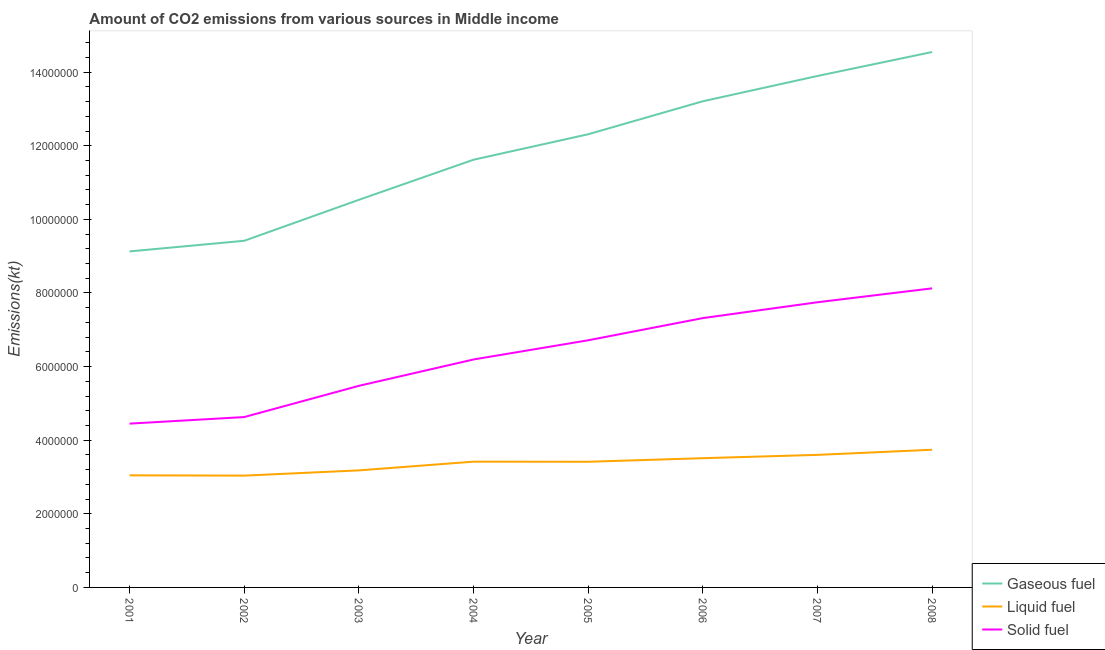How many different coloured lines are there?
Your answer should be very brief. 3. Does the line corresponding to amount of co2 emissions from gaseous fuel intersect with the line corresponding to amount of co2 emissions from solid fuel?
Provide a succinct answer. No. What is the amount of co2 emissions from solid fuel in 2003?
Ensure brevity in your answer.  5.48e+06. Across all years, what is the maximum amount of co2 emissions from gaseous fuel?
Ensure brevity in your answer.  1.45e+07. Across all years, what is the minimum amount of co2 emissions from liquid fuel?
Your answer should be very brief. 3.04e+06. In which year was the amount of co2 emissions from gaseous fuel maximum?
Your response must be concise. 2008. What is the total amount of co2 emissions from solid fuel in the graph?
Make the answer very short. 5.07e+07. What is the difference between the amount of co2 emissions from gaseous fuel in 2003 and that in 2008?
Give a very brief answer. -4.02e+06. What is the difference between the amount of co2 emissions from liquid fuel in 2008 and the amount of co2 emissions from solid fuel in 2001?
Keep it short and to the point. -7.10e+05. What is the average amount of co2 emissions from gaseous fuel per year?
Your answer should be compact. 1.18e+07. In the year 2008, what is the difference between the amount of co2 emissions from liquid fuel and amount of co2 emissions from gaseous fuel?
Your response must be concise. -1.08e+07. In how many years, is the amount of co2 emissions from gaseous fuel greater than 12000000 kt?
Your answer should be very brief. 4. What is the ratio of the amount of co2 emissions from liquid fuel in 2001 to that in 2008?
Provide a short and direct response. 0.81. Is the difference between the amount of co2 emissions from gaseous fuel in 2006 and 2008 greater than the difference between the amount of co2 emissions from solid fuel in 2006 and 2008?
Your answer should be compact. No. What is the difference between the highest and the second highest amount of co2 emissions from solid fuel?
Give a very brief answer. 3.77e+05. What is the difference between the highest and the lowest amount of co2 emissions from solid fuel?
Provide a short and direct response. 3.68e+06. In how many years, is the amount of co2 emissions from liquid fuel greater than the average amount of co2 emissions from liquid fuel taken over all years?
Make the answer very short. 5. Is it the case that in every year, the sum of the amount of co2 emissions from gaseous fuel and amount of co2 emissions from liquid fuel is greater than the amount of co2 emissions from solid fuel?
Give a very brief answer. Yes. Is the amount of co2 emissions from solid fuel strictly less than the amount of co2 emissions from liquid fuel over the years?
Your answer should be compact. No. How many years are there in the graph?
Offer a terse response. 8. Are the values on the major ticks of Y-axis written in scientific E-notation?
Ensure brevity in your answer.  No. Does the graph contain grids?
Ensure brevity in your answer.  No. Where does the legend appear in the graph?
Ensure brevity in your answer.  Bottom right. How many legend labels are there?
Make the answer very short. 3. How are the legend labels stacked?
Give a very brief answer. Vertical. What is the title of the graph?
Ensure brevity in your answer.  Amount of CO2 emissions from various sources in Middle income. Does "Argument" appear as one of the legend labels in the graph?
Your answer should be very brief. No. What is the label or title of the X-axis?
Offer a terse response. Year. What is the label or title of the Y-axis?
Provide a short and direct response. Emissions(kt). What is the Emissions(kt) in Gaseous fuel in 2001?
Provide a short and direct response. 9.13e+06. What is the Emissions(kt) of Liquid fuel in 2001?
Provide a succinct answer. 3.05e+06. What is the Emissions(kt) in Solid fuel in 2001?
Give a very brief answer. 4.45e+06. What is the Emissions(kt) in Gaseous fuel in 2002?
Keep it short and to the point. 9.42e+06. What is the Emissions(kt) of Liquid fuel in 2002?
Provide a succinct answer. 3.04e+06. What is the Emissions(kt) of Solid fuel in 2002?
Provide a succinct answer. 4.63e+06. What is the Emissions(kt) in Gaseous fuel in 2003?
Your answer should be very brief. 1.05e+07. What is the Emissions(kt) of Liquid fuel in 2003?
Your response must be concise. 3.18e+06. What is the Emissions(kt) of Solid fuel in 2003?
Give a very brief answer. 5.48e+06. What is the Emissions(kt) of Gaseous fuel in 2004?
Your answer should be compact. 1.16e+07. What is the Emissions(kt) in Liquid fuel in 2004?
Give a very brief answer. 3.42e+06. What is the Emissions(kt) in Solid fuel in 2004?
Offer a very short reply. 6.19e+06. What is the Emissions(kt) of Gaseous fuel in 2005?
Give a very brief answer. 1.23e+07. What is the Emissions(kt) in Liquid fuel in 2005?
Offer a very short reply. 3.41e+06. What is the Emissions(kt) of Solid fuel in 2005?
Ensure brevity in your answer.  6.71e+06. What is the Emissions(kt) of Gaseous fuel in 2006?
Your response must be concise. 1.32e+07. What is the Emissions(kt) of Liquid fuel in 2006?
Offer a terse response. 3.51e+06. What is the Emissions(kt) in Solid fuel in 2006?
Your answer should be very brief. 7.32e+06. What is the Emissions(kt) in Gaseous fuel in 2007?
Ensure brevity in your answer.  1.39e+07. What is the Emissions(kt) in Liquid fuel in 2007?
Give a very brief answer. 3.60e+06. What is the Emissions(kt) in Solid fuel in 2007?
Offer a terse response. 7.75e+06. What is the Emissions(kt) in Gaseous fuel in 2008?
Your response must be concise. 1.45e+07. What is the Emissions(kt) in Liquid fuel in 2008?
Give a very brief answer. 3.74e+06. What is the Emissions(kt) in Solid fuel in 2008?
Offer a very short reply. 8.13e+06. Across all years, what is the maximum Emissions(kt) in Gaseous fuel?
Make the answer very short. 1.45e+07. Across all years, what is the maximum Emissions(kt) of Liquid fuel?
Make the answer very short. 3.74e+06. Across all years, what is the maximum Emissions(kt) of Solid fuel?
Offer a terse response. 8.13e+06. Across all years, what is the minimum Emissions(kt) in Gaseous fuel?
Offer a very short reply. 9.13e+06. Across all years, what is the minimum Emissions(kt) in Liquid fuel?
Keep it short and to the point. 3.04e+06. Across all years, what is the minimum Emissions(kt) of Solid fuel?
Your answer should be compact. 4.45e+06. What is the total Emissions(kt) in Gaseous fuel in the graph?
Provide a short and direct response. 9.47e+07. What is the total Emissions(kt) in Liquid fuel in the graph?
Ensure brevity in your answer.  2.69e+07. What is the total Emissions(kt) of Solid fuel in the graph?
Offer a terse response. 5.07e+07. What is the difference between the Emissions(kt) in Gaseous fuel in 2001 and that in 2002?
Give a very brief answer. -2.88e+05. What is the difference between the Emissions(kt) in Liquid fuel in 2001 and that in 2002?
Offer a terse response. 7887.68. What is the difference between the Emissions(kt) of Solid fuel in 2001 and that in 2002?
Offer a terse response. -1.78e+05. What is the difference between the Emissions(kt) in Gaseous fuel in 2001 and that in 2003?
Ensure brevity in your answer.  -1.40e+06. What is the difference between the Emissions(kt) of Liquid fuel in 2001 and that in 2003?
Provide a succinct answer. -1.35e+05. What is the difference between the Emissions(kt) in Solid fuel in 2001 and that in 2003?
Offer a terse response. -1.03e+06. What is the difference between the Emissions(kt) of Gaseous fuel in 2001 and that in 2004?
Ensure brevity in your answer.  -2.49e+06. What is the difference between the Emissions(kt) in Liquid fuel in 2001 and that in 2004?
Provide a short and direct response. -3.71e+05. What is the difference between the Emissions(kt) in Solid fuel in 2001 and that in 2004?
Provide a succinct answer. -1.74e+06. What is the difference between the Emissions(kt) of Gaseous fuel in 2001 and that in 2005?
Provide a short and direct response. -3.18e+06. What is the difference between the Emissions(kt) of Liquid fuel in 2001 and that in 2005?
Keep it short and to the point. -3.68e+05. What is the difference between the Emissions(kt) in Solid fuel in 2001 and that in 2005?
Provide a succinct answer. -2.26e+06. What is the difference between the Emissions(kt) in Gaseous fuel in 2001 and that in 2006?
Give a very brief answer. -4.08e+06. What is the difference between the Emissions(kt) in Liquid fuel in 2001 and that in 2006?
Ensure brevity in your answer.  -4.66e+05. What is the difference between the Emissions(kt) in Solid fuel in 2001 and that in 2006?
Give a very brief answer. -2.87e+06. What is the difference between the Emissions(kt) in Gaseous fuel in 2001 and that in 2007?
Ensure brevity in your answer.  -4.77e+06. What is the difference between the Emissions(kt) of Liquid fuel in 2001 and that in 2007?
Ensure brevity in your answer.  -5.56e+05. What is the difference between the Emissions(kt) of Solid fuel in 2001 and that in 2007?
Your answer should be very brief. -3.30e+06. What is the difference between the Emissions(kt) in Gaseous fuel in 2001 and that in 2008?
Give a very brief answer. -5.42e+06. What is the difference between the Emissions(kt) in Liquid fuel in 2001 and that in 2008?
Your answer should be very brief. -6.95e+05. What is the difference between the Emissions(kt) of Solid fuel in 2001 and that in 2008?
Your response must be concise. -3.68e+06. What is the difference between the Emissions(kt) in Gaseous fuel in 2002 and that in 2003?
Give a very brief answer. -1.11e+06. What is the difference between the Emissions(kt) of Liquid fuel in 2002 and that in 2003?
Provide a succinct answer. -1.43e+05. What is the difference between the Emissions(kt) in Solid fuel in 2002 and that in 2003?
Offer a terse response. -8.48e+05. What is the difference between the Emissions(kt) of Gaseous fuel in 2002 and that in 2004?
Your answer should be compact. -2.20e+06. What is the difference between the Emissions(kt) in Liquid fuel in 2002 and that in 2004?
Provide a succinct answer. -3.79e+05. What is the difference between the Emissions(kt) of Solid fuel in 2002 and that in 2004?
Ensure brevity in your answer.  -1.56e+06. What is the difference between the Emissions(kt) in Gaseous fuel in 2002 and that in 2005?
Make the answer very short. -2.89e+06. What is the difference between the Emissions(kt) in Liquid fuel in 2002 and that in 2005?
Offer a very short reply. -3.76e+05. What is the difference between the Emissions(kt) of Solid fuel in 2002 and that in 2005?
Your answer should be very brief. -2.09e+06. What is the difference between the Emissions(kt) in Gaseous fuel in 2002 and that in 2006?
Provide a succinct answer. -3.79e+06. What is the difference between the Emissions(kt) in Liquid fuel in 2002 and that in 2006?
Your answer should be compact. -4.74e+05. What is the difference between the Emissions(kt) in Solid fuel in 2002 and that in 2006?
Keep it short and to the point. -2.69e+06. What is the difference between the Emissions(kt) of Gaseous fuel in 2002 and that in 2007?
Keep it short and to the point. -4.48e+06. What is the difference between the Emissions(kt) of Liquid fuel in 2002 and that in 2007?
Your answer should be compact. -5.64e+05. What is the difference between the Emissions(kt) in Solid fuel in 2002 and that in 2007?
Keep it short and to the point. -3.12e+06. What is the difference between the Emissions(kt) of Gaseous fuel in 2002 and that in 2008?
Keep it short and to the point. -5.13e+06. What is the difference between the Emissions(kt) of Liquid fuel in 2002 and that in 2008?
Your response must be concise. -7.03e+05. What is the difference between the Emissions(kt) in Solid fuel in 2002 and that in 2008?
Provide a succinct answer. -3.50e+06. What is the difference between the Emissions(kt) in Gaseous fuel in 2003 and that in 2004?
Your answer should be very brief. -1.09e+06. What is the difference between the Emissions(kt) of Liquid fuel in 2003 and that in 2004?
Offer a very short reply. -2.37e+05. What is the difference between the Emissions(kt) of Solid fuel in 2003 and that in 2004?
Your answer should be compact. -7.16e+05. What is the difference between the Emissions(kt) of Gaseous fuel in 2003 and that in 2005?
Your response must be concise. -1.78e+06. What is the difference between the Emissions(kt) in Liquid fuel in 2003 and that in 2005?
Your answer should be compact. -2.34e+05. What is the difference between the Emissions(kt) in Solid fuel in 2003 and that in 2005?
Your response must be concise. -1.24e+06. What is the difference between the Emissions(kt) of Gaseous fuel in 2003 and that in 2006?
Ensure brevity in your answer.  -2.68e+06. What is the difference between the Emissions(kt) in Liquid fuel in 2003 and that in 2006?
Your response must be concise. -3.31e+05. What is the difference between the Emissions(kt) in Solid fuel in 2003 and that in 2006?
Your answer should be very brief. -1.84e+06. What is the difference between the Emissions(kt) of Gaseous fuel in 2003 and that in 2007?
Your answer should be compact. -3.36e+06. What is the difference between the Emissions(kt) of Liquid fuel in 2003 and that in 2007?
Your answer should be very brief. -4.21e+05. What is the difference between the Emissions(kt) in Solid fuel in 2003 and that in 2007?
Offer a very short reply. -2.27e+06. What is the difference between the Emissions(kt) of Gaseous fuel in 2003 and that in 2008?
Your answer should be compact. -4.02e+06. What is the difference between the Emissions(kt) in Liquid fuel in 2003 and that in 2008?
Your response must be concise. -5.60e+05. What is the difference between the Emissions(kt) in Solid fuel in 2003 and that in 2008?
Your answer should be compact. -2.65e+06. What is the difference between the Emissions(kt) of Gaseous fuel in 2004 and that in 2005?
Offer a terse response. -6.92e+05. What is the difference between the Emissions(kt) in Liquid fuel in 2004 and that in 2005?
Provide a succinct answer. 2978.89. What is the difference between the Emissions(kt) of Solid fuel in 2004 and that in 2005?
Your response must be concise. -5.22e+05. What is the difference between the Emissions(kt) in Gaseous fuel in 2004 and that in 2006?
Provide a short and direct response. -1.59e+06. What is the difference between the Emissions(kt) of Liquid fuel in 2004 and that in 2006?
Offer a terse response. -9.44e+04. What is the difference between the Emissions(kt) in Solid fuel in 2004 and that in 2006?
Your answer should be compact. -1.12e+06. What is the difference between the Emissions(kt) in Gaseous fuel in 2004 and that in 2007?
Provide a succinct answer. -2.28e+06. What is the difference between the Emissions(kt) in Liquid fuel in 2004 and that in 2007?
Your answer should be very brief. -1.84e+05. What is the difference between the Emissions(kt) in Solid fuel in 2004 and that in 2007?
Ensure brevity in your answer.  -1.55e+06. What is the difference between the Emissions(kt) of Gaseous fuel in 2004 and that in 2008?
Offer a terse response. -2.93e+06. What is the difference between the Emissions(kt) of Liquid fuel in 2004 and that in 2008?
Offer a terse response. -3.24e+05. What is the difference between the Emissions(kt) in Solid fuel in 2004 and that in 2008?
Make the answer very short. -1.93e+06. What is the difference between the Emissions(kt) of Gaseous fuel in 2005 and that in 2006?
Offer a very short reply. -8.96e+05. What is the difference between the Emissions(kt) in Liquid fuel in 2005 and that in 2006?
Your answer should be very brief. -9.74e+04. What is the difference between the Emissions(kt) of Solid fuel in 2005 and that in 2006?
Provide a succinct answer. -6.02e+05. What is the difference between the Emissions(kt) in Gaseous fuel in 2005 and that in 2007?
Provide a short and direct response. -1.58e+06. What is the difference between the Emissions(kt) of Liquid fuel in 2005 and that in 2007?
Keep it short and to the point. -1.87e+05. What is the difference between the Emissions(kt) in Solid fuel in 2005 and that in 2007?
Your answer should be compact. -1.03e+06. What is the difference between the Emissions(kt) in Gaseous fuel in 2005 and that in 2008?
Make the answer very short. -2.23e+06. What is the difference between the Emissions(kt) of Liquid fuel in 2005 and that in 2008?
Make the answer very short. -3.27e+05. What is the difference between the Emissions(kt) of Solid fuel in 2005 and that in 2008?
Provide a succinct answer. -1.41e+06. What is the difference between the Emissions(kt) in Gaseous fuel in 2006 and that in 2007?
Provide a short and direct response. -6.87e+05. What is the difference between the Emissions(kt) in Liquid fuel in 2006 and that in 2007?
Provide a succinct answer. -8.99e+04. What is the difference between the Emissions(kt) of Solid fuel in 2006 and that in 2007?
Your answer should be very brief. -4.31e+05. What is the difference between the Emissions(kt) of Gaseous fuel in 2006 and that in 2008?
Make the answer very short. -1.34e+06. What is the difference between the Emissions(kt) of Liquid fuel in 2006 and that in 2008?
Ensure brevity in your answer.  -2.29e+05. What is the difference between the Emissions(kt) in Solid fuel in 2006 and that in 2008?
Keep it short and to the point. -8.08e+05. What is the difference between the Emissions(kt) of Gaseous fuel in 2007 and that in 2008?
Give a very brief answer. -6.51e+05. What is the difference between the Emissions(kt) of Liquid fuel in 2007 and that in 2008?
Provide a succinct answer. -1.39e+05. What is the difference between the Emissions(kt) in Solid fuel in 2007 and that in 2008?
Offer a very short reply. -3.77e+05. What is the difference between the Emissions(kt) of Gaseous fuel in 2001 and the Emissions(kt) of Liquid fuel in 2002?
Offer a terse response. 6.09e+06. What is the difference between the Emissions(kt) in Gaseous fuel in 2001 and the Emissions(kt) in Solid fuel in 2002?
Make the answer very short. 4.50e+06. What is the difference between the Emissions(kt) in Liquid fuel in 2001 and the Emissions(kt) in Solid fuel in 2002?
Your answer should be compact. -1.58e+06. What is the difference between the Emissions(kt) in Gaseous fuel in 2001 and the Emissions(kt) in Liquid fuel in 2003?
Offer a terse response. 5.95e+06. What is the difference between the Emissions(kt) of Gaseous fuel in 2001 and the Emissions(kt) of Solid fuel in 2003?
Keep it short and to the point. 3.65e+06. What is the difference between the Emissions(kt) of Liquid fuel in 2001 and the Emissions(kt) of Solid fuel in 2003?
Keep it short and to the point. -2.43e+06. What is the difference between the Emissions(kt) of Gaseous fuel in 2001 and the Emissions(kt) of Liquid fuel in 2004?
Offer a terse response. 5.71e+06. What is the difference between the Emissions(kt) of Gaseous fuel in 2001 and the Emissions(kt) of Solid fuel in 2004?
Give a very brief answer. 2.94e+06. What is the difference between the Emissions(kt) of Liquid fuel in 2001 and the Emissions(kt) of Solid fuel in 2004?
Your answer should be very brief. -3.15e+06. What is the difference between the Emissions(kt) of Gaseous fuel in 2001 and the Emissions(kt) of Liquid fuel in 2005?
Offer a very short reply. 5.72e+06. What is the difference between the Emissions(kt) of Gaseous fuel in 2001 and the Emissions(kt) of Solid fuel in 2005?
Provide a short and direct response. 2.41e+06. What is the difference between the Emissions(kt) in Liquid fuel in 2001 and the Emissions(kt) in Solid fuel in 2005?
Your answer should be very brief. -3.67e+06. What is the difference between the Emissions(kt) of Gaseous fuel in 2001 and the Emissions(kt) of Liquid fuel in 2006?
Your response must be concise. 5.62e+06. What is the difference between the Emissions(kt) in Gaseous fuel in 2001 and the Emissions(kt) in Solid fuel in 2006?
Ensure brevity in your answer.  1.81e+06. What is the difference between the Emissions(kt) in Liquid fuel in 2001 and the Emissions(kt) in Solid fuel in 2006?
Keep it short and to the point. -4.27e+06. What is the difference between the Emissions(kt) in Gaseous fuel in 2001 and the Emissions(kt) in Liquid fuel in 2007?
Give a very brief answer. 5.53e+06. What is the difference between the Emissions(kt) of Gaseous fuel in 2001 and the Emissions(kt) of Solid fuel in 2007?
Offer a very short reply. 1.38e+06. What is the difference between the Emissions(kt) in Liquid fuel in 2001 and the Emissions(kt) in Solid fuel in 2007?
Your answer should be compact. -4.70e+06. What is the difference between the Emissions(kt) in Gaseous fuel in 2001 and the Emissions(kt) in Liquid fuel in 2008?
Offer a very short reply. 5.39e+06. What is the difference between the Emissions(kt) in Gaseous fuel in 2001 and the Emissions(kt) in Solid fuel in 2008?
Your answer should be very brief. 1.00e+06. What is the difference between the Emissions(kt) in Liquid fuel in 2001 and the Emissions(kt) in Solid fuel in 2008?
Your answer should be compact. -5.08e+06. What is the difference between the Emissions(kt) of Gaseous fuel in 2002 and the Emissions(kt) of Liquid fuel in 2003?
Keep it short and to the point. 6.24e+06. What is the difference between the Emissions(kt) in Gaseous fuel in 2002 and the Emissions(kt) in Solid fuel in 2003?
Ensure brevity in your answer.  3.94e+06. What is the difference between the Emissions(kt) in Liquid fuel in 2002 and the Emissions(kt) in Solid fuel in 2003?
Your response must be concise. -2.44e+06. What is the difference between the Emissions(kt) in Gaseous fuel in 2002 and the Emissions(kt) in Liquid fuel in 2004?
Your answer should be compact. 6.00e+06. What is the difference between the Emissions(kt) of Gaseous fuel in 2002 and the Emissions(kt) of Solid fuel in 2004?
Keep it short and to the point. 3.22e+06. What is the difference between the Emissions(kt) of Liquid fuel in 2002 and the Emissions(kt) of Solid fuel in 2004?
Keep it short and to the point. -3.16e+06. What is the difference between the Emissions(kt) in Gaseous fuel in 2002 and the Emissions(kt) in Liquid fuel in 2005?
Your answer should be very brief. 6.00e+06. What is the difference between the Emissions(kt) in Gaseous fuel in 2002 and the Emissions(kt) in Solid fuel in 2005?
Provide a succinct answer. 2.70e+06. What is the difference between the Emissions(kt) of Liquid fuel in 2002 and the Emissions(kt) of Solid fuel in 2005?
Offer a terse response. -3.68e+06. What is the difference between the Emissions(kt) of Gaseous fuel in 2002 and the Emissions(kt) of Liquid fuel in 2006?
Offer a very short reply. 5.91e+06. What is the difference between the Emissions(kt) in Gaseous fuel in 2002 and the Emissions(kt) in Solid fuel in 2006?
Ensure brevity in your answer.  2.10e+06. What is the difference between the Emissions(kt) of Liquid fuel in 2002 and the Emissions(kt) of Solid fuel in 2006?
Provide a short and direct response. -4.28e+06. What is the difference between the Emissions(kt) in Gaseous fuel in 2002 and the Emissions(kt) in Liquid fuel in 2007?
Provide a succinct answer. 5.82e+06. What is the difference between the Emissions(kt) of Gaseous fuel in 2002 and the Emissions(kt) of Solid fuel in 2007?
Ensure brevity in your answer.  1.67e+06. What is the difference between the Emissions(kt) in Liquid fuel in 2002 and the Emissions(kt) in Solid fuel in 2007?
Provide a short and direct response. -4.71e+06. What is the difference between the Emissions(kt) in Gaseous fuel in 2002 and the Emissions(kt) in Liquid fuel in 2008?
Your response must be concise. 5.68e+06. What is the difference between the Emissions(kt) in Gaseous fuel in 2002 and the Emissions(kt) in Solid fuel in 2008?
Provide a short and direct response. 1.29e+06. What is the difference between the Emissions(kt) of Liquid fuel in 2002 and the Emissions(kt) of Solid fuel in 2008?
Keep it short and to the point. -5.09e+06. What is the difference between the Emissions(kt) of Gaseous fuel in 2003 and the Emissions(kt) of Liquid fuel in 2004?
Provide a short and direct response. 7.11e+06. What is the difference between the Emissions(kt) in Gaseous fuel in 2003 and the Emissions(kt) in Solid fuel in 2004?
Provide a succinct answer. 4.34e+06. What is the difference between the Emissions(kt) in Liquid fuel in 2003 and the Emissions(kt) in Solid fuel in 2004?
Your response must be concise. -3.01e+06. What is the difference between the Emissions(kt) of Gaseous fuel in 2003 and the Emissions(kt) of Liquid fuel in 2005?
Keep it short and to the point. 7.12e+06. What is the difference between the Emissions(kt) of Gaseous fuel in 2003 and the Emissions(kt) of Solid fuel in 2005?
Your response must be concise. 3.82e+06. What is the difference between the Emissions(kt) of Liquid fuel in 2003 and the Emissions(kt) of Solid fuel in 2005?
Provide a short and direct response. -3.53e+06. What is the difference between the Emissions(kt) of Gaseous fuel in 2003 and the Emissions(kt) of Liquid fuel in 2006?
Provide a short and direct response. 7.02e+06. What is the difference between the Emissions(kt) in Gaseous fuel in 2003 and the Emissions(kt) in Solid fuel in 2006?
Offer a terse response. 3.21e+06. What is the difference between the Emissions(kt) of Liquid fuel in 2003 and the Emissions(kt) of Solid fuel in 2006?
Provide a succinct answer. -4.14e+06. What is the difference between the Emissions(kt) of Gaseous fuel in 2003 and the Emissions(kt) of Liquid fuel in 2007?
Make the answer very short. 6.93e+06. What is the difference between the Emissions(kt) of Gaseous fuel in 2003 and the Emissions(kt) of Solid fuel in 2007?
Offer a terse response. 2.78e+06. What is the difference between the Emissions(kt) in Liquid fuel in 2003 and the Emissions(kt) in Solid fuel in 2007?
Your response must be concise. -4.57e+06. What is the difference between the Emissions(kt) in Gaseous fuel in 2003 and the Emissions(kt) in Liquid fuel in 2008?
Provide a succinct answer. 6.79e+06. What is the difference between the Emissions(kt) in Gaseous fuel in 2003 and the Emissions(kt) in Solid fuel in 2008?
Give a very brief answer. 2.41e+06. What is the difference between the Emissions(kt) in Liquid fuel in 2003 and the Emissions(kt) in Solid fuel in 2008?
Your answer should be compact. -4.95e+06. What is the difference between the Emissions(kt) of Gaseous fuel in 2004 and the Emissions(kt) of Liquid fuel in 2005?
Offer a terse response. 8.21e+06. What is the difference between the Emissions(kt) of Gaseous fuel in 2004 and the Emissions(kt) of Solid fuel in 2005?
Provide a short and direct response. 4.91e+06. What is the difference between the Emissions(kt) in Liquid fuel in 2004 and the Emissions(kt) in Solid fuel in 2005?
Provide a short and direct response. -3.30e+06. What is the difference between the Emissions(kt) in Gaseous fuel in 2004 and the Emissions(kt) in Liquid fuel in 2006?
Provide a succinct answer. 8.11e+06. What is the difference between the Emissions(kt) in Gaseous fuel in 2004 and the Emissions(kt) in Solid fuel in 2006?
Keep it short and to the point. 4.30e+06. What is the difference between the Emissions(kt) in Liquid fuel in 2004 and the Emissions(kt) in Solid fuel in 2006?
Offer a terse response. -3.90e+06. What is the difference between the Emissions(kt) in Gaseous fuel in 2004 and the Emissions(kt) in Liquid fuel in 2007?
Keep it short and to the point. 8.02e+06. What is the difference between the Emissions(kt) of Gaseous fuel in 2004 and the Emissions(kt) of Solid fuel in 2007?
Provide a succinct answer. 3.87e+06. What is the difference between the Emissions(kt) in Liquid fuel in 2004 and the Emissions(kt) in Solid fuel in 2007?
Provide a succinct answer. -4.33e+06. What is the difference between the Emissions(kt) of Gaseous fuel in 2004 and the Emissions(kt) of Liquid fuel in 2008?
Your answer should be compact. 7.88e+06. What is the difference between the Emissions(kt) of Gaseous fuel in 2004 and the Emissions(kt) of Solid fuel in 2008?
Make the answer very short. 3.49e+06. What is the difference between the Emissions(kt) in Liquid fuel in 2004 and the Emissions(kt) in Solid fuel in 2008?
Your answer should be compact. -4.71e+06. What is the difference between the Emissions(kt) in Gaseous fuel in 2005 and the Emissions(kt) in Liquid fuel in 2006?
Keep it short and to the point. 8.80e+06. What is the difference between the Emissions(kt) in Gaseous fuel in 2005 and the Emissions(kt) in Solid fuel in 2006?
Your answer should be very brief. 4.99e+06. What is the difference between the Emissions(kt) of Liquid fuel in 2005 and the Emissions(kt) of Solid fuel in 2006?
Ensure brevity in your answer.  -3.90e+06. What is the difference between the Emissions(kt) in Gaseous fuel in 2005 and the Emissions(kt) in Liquid fuel in 2007?
Your answer should be very brief. 8.71e+06. What is the difference between the Emissions(kt) in Gaseous fuel in 2005 and the Emissions(kt) in Solid fuel in 2007?
Ensure brevity in your answer.  4.56e+06. What is the difference between the Emissions(kt) in Liquid fuel in 2005 and the Emissions(kt) in Solid fuel in 2007?
Make the answer very short. -4.33e+06. What is the difference between the Emissions(kt) in Gaseous fuel in 2005 and the Emissions(kt) in Liquid fuel in 2008?
Offer a very short reply. 8.57e+06. What is the difference between the Emissions(kt) of Gaseous fuel in 2005 and the Emissions(kt) of Solid fuel in 2008?
Make the answer very short. 4.19e+06. What is the difference between the Emissions(kt) of Liquid fuel in 2005 and the Emissions(kt) of Solid fuel in 2008?
Make the answer very short. -4.71e+06. What is the difference between the Emissions(kt) in Gaseous fuel in 2006 and the Emissions(kt) in Liquid fuel in 2007?
Keep it short and to the point. 9.61e+06. What is the difference between the Emissions(kt) of Gaseous fuel in 2006 and the Emissions(kt) of Solid fuel in 2007?
Your response must be concise. 5.46e+06. What is the difference between the Emissions(kt) in Liquid fuel in 2006 and the Emissions(kt) in Solid fuel in 2007?
Your response must be concise. -4.24e+06. What is the difference between the Emissions(kt) in Gaseous fuel in 2006 and the Emissions(kt) in Liquid fuel in 2008?
Ensure brevity in your answer.  9.47e+06. What is the difference between the Emissions(kt) of Gaseous fuel in 2006 and the Emissions(kt) of Solid fuel in 2008?
Provide a short and direct response. 5.08e+06. What is the difference between the Emissions(kt) in Liquid fuel in 2006 and the Emissions(kt) in Solid fuel in 2008?
Make the answer very short. -4.61e+06. What is the difference between the Emissions(kt) of Gaseous fuel in 2007 and the Emissions(kt) of Liquid fuel in 2008?
Provide a succinct answer. 1.02e+07. What is the difference between the Emissions(kt) in Gaseous fuel in 2007 and the Emissions(kt) in Solid fuel in 2008?
Keep it short and to the point. 5.77e+06. What is the difference between the Emissions(kt) in Liquid fuel in 2007 and the Emissions(kt) in Solid fuel in 2008?
Your answer should be very brief. -4.52e+06. What is the average Emissions(kt) of Gaseous fuel per year?
Offer a very short reply. 1.18e+07. What is the average Emissions(kt) in Liquid fuel per year?
Offer a terse response. 3.37e+06. What is the average Emissions(kt) of Solid fuel per year?
Your answer should be compact. 6.33e+06. In the year 2001, what is the difference between the Emissions(kt) of Gaseous fuel and Emissions(kt) of Liquid fuel?
Your response must be concise. 6.08e+06. In the year 2001, what is the difference between the Emissions(kt) in Gaseous fuel and Emissions(kt) in Solid fuel?
Provide a succinct answer. 4.68e+06. In the year 2001, what is the difference between the Emissions(kt) of Liquid fuel and Emissions(kt) of Solid fuel?
Ensure brevity in your answer.  -1.41e+06. In the year 2002, what is the difference between the Emissions(kt) of Gaseous fuel and Emissions(kt) of Liquid fuel?
Your answer should be very brief. 6.38e+06. In the year 2002, what is the difference between the Emissions(kt) in Gaseous fuel and Emissions(kt) in Solid fuel?
Ensure brevity in your answer.  4.79e+06. In the year 2002, what is the difference between the Emissions(kt) of Liquid fuel and Emissions(kt) of Solid fuel?
Keep it short and to the point. -1.59e+06. In the year 2003, what is the difference between the Emissions(kt) of Gaseous fuel and Emissions(kt) of Liquid fuel?
Your response must be concise. 7.35e+06. In the year 2003, what is the difference between the Emissions(kt) in Gaseous fuel and Emissions(kt) in Solid fuel?
Make the answer very short. 5.05e+06. In the year 2003, what is the difference between the Emissions(kt) in Liquid fuel and Emissions(kt) in Solid fuel?
Offer a very short reply. -2.30e+06. In the year 2004, what is the difference between the Emissions(kt) of Gaseous fuel and Emissions(kt) of Liquid fuel?
Keep it short and to the point. 8.20e+06. In the year 2004, what is the difference between the Emissions(kt) of Gaseous fuel and Emissions(kt) of Solid fuel?
Keep it short and to the point. 5.43e+06. In the year 2004, what is the difference between the Emissions(kt) in Liquid fuel and Emissions(kt) in Solid fuel?
Keep it short and to the point. -2.78e+06. In the year 2005, what is the difference between the Emissions(kt) in Gaseous fuel and Emissions(kt) in Liquid fuel?
Offer a very short reply. 8.90e+06. In the year 2005, what is the difference between the Emissions(kt) of Gaseous fuel and Emissions(kt) of Solid fuel?
Make the answer very short. 5.60e+06. In the year 2005, what is the difference between the Emissions(kt) of Liquid fuel and Emissions(kt) of Solid fuel?
Offer a terse response. -3.30e+06. In the year 2006, what is the difference between the Emissions(kt) in Gaseous fuel and Emissions(kt) in Liquid fuel?
Your answer should be compact. 9.70e+06. In the year 2006, what is the difference between the Emissions(kt) in Gaseous fuel and Emissions(kt) in Solid fuel?
Offer a terse response. 5.89e+06. In the year 2006, what is the difference between the Emissions(kt) in Liquid fuel and Emissions(kt) in Solid fuel?
Provide a succinct answer. -3.81e+06. In the year 2007, what is the difference between the Emissions(kt) of Gaseous fuel and Emissions(kt) of Liquid fuel?
Your answer should be compact. 1.03e+07. In the year 2007, what is the difference between the Emissions(kt) of Gaseous fuel and Emissions(kt) of Solid fuel?
Provide a short and direct response. 6.15e+06. In the year 2007, what is the difference between the Emissions(kt) in Liquid fuel and Emissions(kt) in Solid fuel?
Your answer should be compact. -4.15e+06. In the year 2008, what is the difference between the Emissions(kt) in Gaseous fuel and Emissions(kt) in Liquid fuel?
Keep it short and to the point. 1.08e+07. In the year 2008, what is the difference between the Emissions(kt) of Gaseous fuel and Emissions(kt) of Solid fuel?
Offer a terse response. 6.42e+06. In the year 2008, what is the difference between the Emissions(kt) of Liquid fuel and Emissions(kt) of Solid fuel?
Your response must be concise. -4.39e+06. What is the ratio of the Emissions(kt) of Gaseous fuel in 2001 to that in 2002?
Provide a succinct answer. 0.97. What is the ratio of the Emissions(kt) in Solid fuel in 2001 to that in 2002?
Your answer should be compact. 0.96. What is the ratio of the Emissions(kt) in Gaseous fuel in 2001 to that in 2003?
Make the answer very short. 0.87. What is the ratio of the Emissions(kt) of Liquid fuel in 2001 to that in 2003?
Ensure brevity in your answer.  0.96. What is the ratio of the Emissions(kt) in Solid fuel in 2001 to that in 2003?
Provide a succinct answer. 0.81. What is the ratio of the Emissions(kt) of Gaseous fuel in 2001 to that in 2004?
Your answer should be compact. 0.79. What is the ratio of the Emissions(kt) in Liquid fuel in 2001 to that in 2004?
Offer a terse response. 0.89. What is the ratio of the Emissions(kt) in Solid fuel in 2001 to that in 2004?
Offer a terse response. 0.72. What is the ratio of the Emissions(kt) in Gaseous fuel in 2001 to that in 2005?
Give a very brief answer. 0.74. What is the ratio of the Emissions(kt) of Liquid fuel in 2001 to that in 2005?
Your response must be concise. 0.89. What is the ratio of the Emissions(kt) of Solid fuel in 2001 to that in 2005?
Give a very brief answer. 0.66. What is the ratio of the Emissions(kt) of Gaseous fuel in 2001 to that in 2006?
Keep it short and to the point. 0.69. What is the ratio of the Emissions(kt) of Liquid fuel in 2001 to that in 2006?
Offer a terse response. 0.87. What is the ratio of the Emissions(kt) in Solid fuel in 2001 to that in 2006?
Offer a terse response. 0.61. What is the ratio of the Emissions(kt) in Gaseous fuel in 2001 to that in 2007?
Keep it short and to the point. 0.66. What is the ratio of the Emissions(kt) in Liquid fuel in 2001 to that in 2007?
Your response must be concise. 0.85. What is the ratio of the Emissions(kt) of Solid fuel in 2001 to that in 2007?
Your answer should be compact. 0.57. What is the ratio of the Emissions(kt) of Gaseous fuel in 2001 to that in 2008?
Provide a succinct answer. 0.63. What is the ratio of the Emissions(kt) in Liquid fuel in 2001 to that in 2008?
Offer a very short reply. 0.81. What is the ratio of the Emissions(kt) in Solid fuel in 2001 to that in 2008?
Your answer should be very brief. 0.55. What is the ratio of the Emissions(kt) of Gaseous fuel in 2002 to that in 2003?
Your answer should be compact. 0.89. What is the ratio of the Emissions(kt) of Liquid fuel in 2002 to that in 2003?
Offer a terse response. 0.96. What is the ratio of the Emissions(kt) of Solid fuel in 2002 to that in 2003?
Provide a short and direct response. 0.85. What is the ratio of the Emissions(kt) in Gaseous fuel in 2002 to that in 2004?
Your response must be concise. 0.81. What is the ratio of the Emissions(kt) of Liquid fuel in 2002 to that in 2004?
Offer a very short reply. 0.89. What is the ratio of the Emissions(kt) of Solid fuel in 2002 to that in 2004?
Offer a very short reply. 0.75. What is the ratio of the Emissions(kt) of Gaseous fuel in 2002 to that in 2005?
Your response must be concise. 0.76. What is the ratio of the Emissions(kt) of Liquid fuel in 2002 to that in 2005?
Provide a succinct answer. 0.89. What is the ratio of the Emissions(kt) in Solid fuel in 2002 to that in 2005?
Provide a succinct answer. 0.69. What is the ratio of the Emissions(kt) of Gaseous fuel in 2002 to that in 2006?
Offer a terse response. 0.71. What is the ratio of the Emissions(kt) of Liquid fuel in 2002 to that in 2006?
Give a very brief answer. 0.87. What is the ratio of the Emissions(kt) of Solid fuel in 2002 to that in 2006?
Your answer should be compact. 0.63. What is the ratio of the Emissions(kt) in Gaseous fuel in 2002 to that in 2007?
Provide a short and direct response. 0.68. What is the ratio of the Emissions(kt) in Liquid fuel in 2002 to that in 2007?
Give a very brief answer. 0.84. What is the ratio of the Emissions(kt) of Solid fuel in 2002 to that in 2007?
Your response must be concise. 0.6. What is the ratio of the Emissions(kt) of Gaseous fuel in 2002 to that in 2008?
Keep it short and to the point. 0.65. What is the ratio of the Emissions(kt) in Liquid fuel in 2002 to that in 2008?
Keep it short and to the point. 0.81. What is the ratio of the Emissions(kt) of Solid fuel in 2002 to that in 2008?
Your response must be concise. 0.57. What is the ratio of the Emissions(kt) of Gaseous fuel in 2003 to that in 2004?
Your answer should be very brief. 0.91. What is the ratio of the Emissions(kt) in Liquid fuel in 2003 to that in 2004?
Provide a short and direct response. 0.93. What is the ratio of the Emissions(kt) of Solid fuel in 2003 to that in 2004?
Provide a short and direct response. 0.88. What is the ratio of the Emissions(kt) in Gaseous fuel in 2003 to that in 2005?
Give a very brief answer. 0.86. What is the ratio of the Emissions(kt) of Liquid fuel in 2003 to that in 2005?
Give a very brief answer. 0.93. What is the ratio of the Emissions(kt) of Solid fuel in 2003 to that in 2005?
Provide a succinct answer. 0.82. What is the ratio of the Emissions(kt) of Gaseous fuel in 2003 to that in 2006?
Make the answer very short. 0.8. What is the ratio of the Emissions(kt) of Liquid fuel in 2003 to that in 2006?
Give a very brief answer. 0.91. What is the ratio of the Emissions(kt) in Solid fuel in 2003 to that in 2006?
Provide a succinct answer. 0.75. What is the ratio of the Emissions(kt) in Gaseous fuel in 2003 to that in 2007?
Your answer should be compact. 0.76. What is the ratio of the Emissions(kt) of Liquid fuel in 2003 to that in 2007?
Offer a very short reply. 0.88. What is the ratio of the Emissions(kt) in Solid fuel in 2003 to that in 2007?
Your response must be concise. 0.71. What is the ratio of the Emissions(kt) in Gaseous fuel in 2003 to that in 2008?
Offer a terse response. 0.72. What is the ratio of the Emissions(kt) in Liquid fuel in 2003 to that in 2008?
Your answer should be compact. 0.85. What is the ratio of the Emissions(kt) in Solid fuel in 2003 to that in 2008?
Your response must be concise. 0.67. What is the ratio of the Emissions(kt) of Gaseous fuel in 2004 to that in 2005?
Provide a short and direct response. 0.94. What is the ratio of the Emissions(kt) in Liquid fuel in 2004 to that in 2005?
Your response must be concise. 1. What is the ratio of the Emissions(kt) in Solid fuel in 2004 to that in 2005?
Ensure brevity in your answer.  0.92. What is the ratio of the Emissions(kt) of Gaseous fuel in 2004 to that in 2006?
Make the answer very short. 0.88. What is the ratio of the Emissions(kt) of Liquid fuel in 2004 to that in 2006?
Make the answer very short. 0.97. What is the ratio of the Emissions(kt) of Solid fuel in 2004 to that in 2006?
Provide a short and direct response. 0.85. What is the ratio of the Emissions(kt) in Gaseous fuel in 2004 to that in 2007?
Keep it short and to the point. 0.84. What is the ratio of the Emissions(kt) in Liquid fuel in 2004 to that in 2007?
Provide a succinct answer. 0.95. What is the ratio of the Emissions(kt) in Solid fuel in 2004 to that in 2007?
Provide a short and direct response. 0.8. What is the ratio of the Emissions(kt) in Gaseous fuel in 2004 to that in 2008?
Your answer should be very brief. 0.8. What is the ratio of the Emissions(kt) of Liquid fuel in 2004 to that in 2008?
Give a very brief answer. 0.91. What is the ratio of the Emissions(kt) in Solid fuel in 2004 to that in 2008?
Provide a short and direct response. 0.76. What is the ratio of the Emissions(kt) of Gaseous fuel in 2005 to that in 2006?
Provide a short and direct response. 0.93. What is the ratio of the Emissions(kt) in Liquid fuel in 2005 to that in 2006?
Your answer should be compact. 0.97. What is the ratio of the Emissions(kt) in Solid fuel in 2005 to that in 2006?
Keep it short and to the point. 0.92. What is the ratio of the Emissions(kt) in Gaseous fuel in 2005 to that in 2007?
Your answer should be compact. 0.89. What is the ratio of the Emissions(kt) of Liquid fuel in 2005 to that in 2007?
Give a very brief answer. 0.95. What is the ratio of the Emissions(kt) in Solid fuel in 2005 to that in 2007?
Your answer should be compact. 0.87. What is the ratio of the Emissions(kt) of Gaseous fuel in 2005 to that in 2008?
Make the answer very short. 0.85. What is the ratio of the Emissions(kt) of Liquid fuel in 2005 to that in 2008?
Provide a short and direct response. 0.91. What is the ratio of the Emissions(kt) of Solid fuel in 2005 to that in 2008?
Keep it short and to the point. 0.83. What is the ratio of the Emissions(kt) of Gaseous fuel in 2006 to that in 2007?
Provide a short and direct response. 0.95. What is the ratio of the Emissions(kt) of Liquid fuel in 2006 to that in 2007?
Provide a succinct answer. 0.97. What is the ratio of the Emissions(kt) of Gaseous fuel in 2006 to that in 2008?
Offer a terse response. 0.91. What is the ratio of the Emissions(kt) in Liquid fuel in 2006 to that in 2008?
Provide a succinct answer. 0.94. What is the ratio of the Emissions(kt) of Solid fuel in 2006 to that in 2008?
Your response must be concise. 0.9. What is the ratio of the Emissions(kt) in Gaseous fuel in 2007 to that in 2008?
Your response must be concise. 0.96. What is the ratio of the Emissions(kt) in Liquid fuel in 2007 to that in 2008?
Your answer should be compact. 0.96. What is the ratio of the Emissions(kt) of Solid fuel in 2007 to that in 2008?
Your answer should be very brief. 0.95. What is the difference between the highest and the second highest Emissions(kt) in Gaseous fuel?
Make the answer very short. 6.51e+05. What is the difference between the highest and the second highest Emissions(kt) in Liquid fuel?
Your answer should be compact. 1.39e+05. What is the difference between the highest and the second highest Emissions(kt) in Solid fuel?
Provide a succinct answer. 3.77e+05. What is the difference between the highest and the lowest Emissions(kt) in Gaseous fuel?
Offer a very short reply. 5.42e+06. What is the difference between the highest and the lowest Emissions(kt) in Liquid fuel?
Your response must be concise. 7.03e+05. What is the difference between the highest and the lowest Emissions(kt) of Solid fuel?
Your answer should be compact. 3.68e+06. 